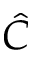Convert formula to latex. <formula><loc_0><loc_0><loc_500><loc_500>\hat { C }</formula> 